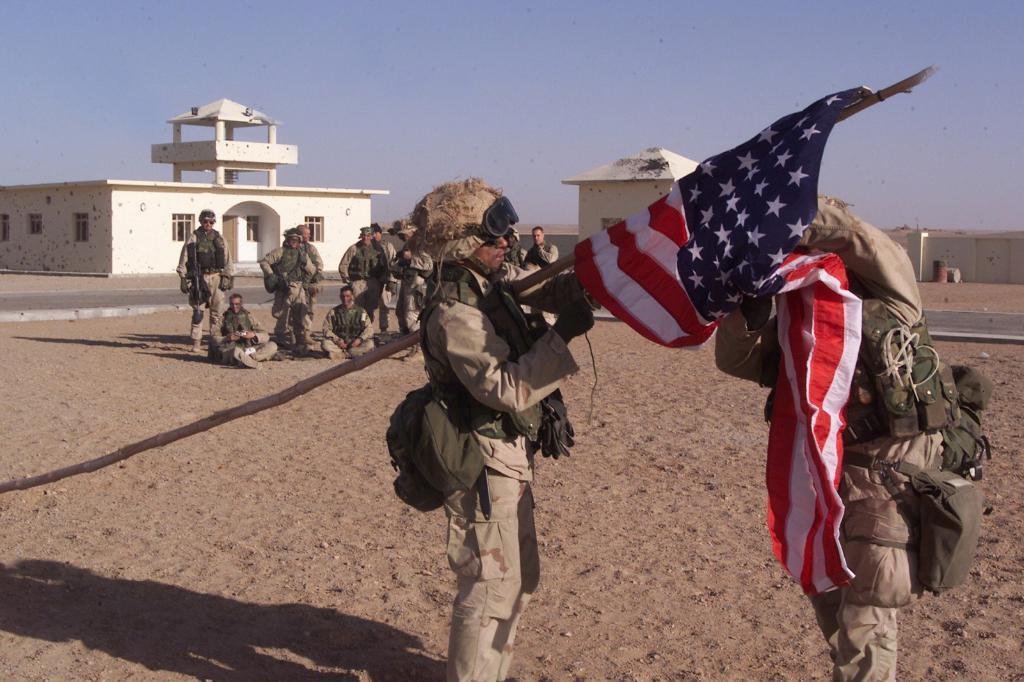Could you give a brief overview of what you see in this image? There is a person holding stick, which is having flag and other persons holding that flag, on the sand surface of a ground. In the background, there are persons sitting on the ground, there are persons standing on the ground, there are buildings, there is a road and there is blue sky. 